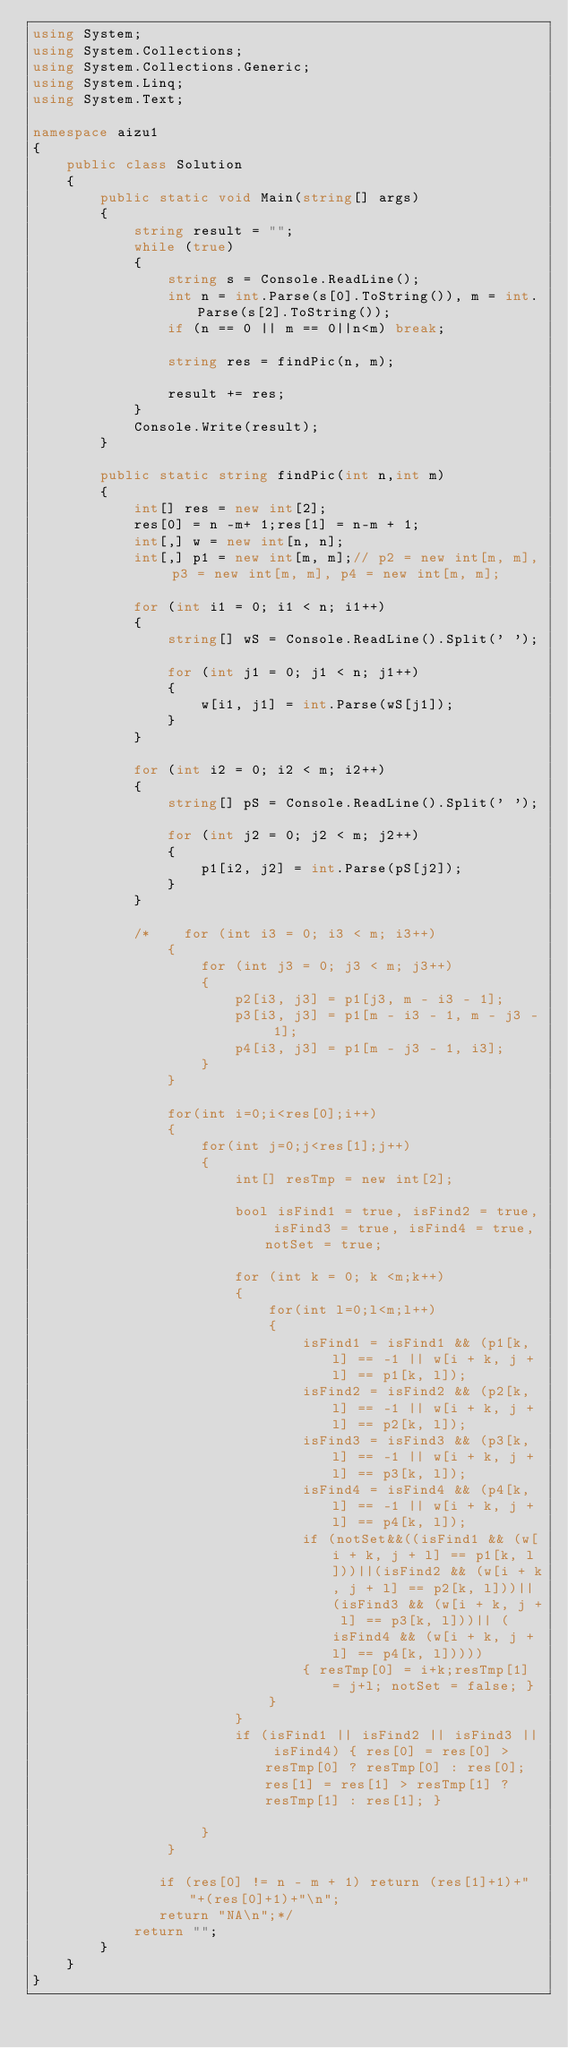<code> <loc_0><loc_0><loc_500><loc_500><_C#_>using System;
using System.Collections;
using System.Collections.Generic;
using System.Linq;
using System.Text;

namespace aizu1
{
    public class Solution
    {
        public static void Main(string[] args)
        {
            string result = "";
            while (true)
            {
                string s = Console.ReadLine();
                int n = int.Parse(s[0].ToString()), m = int.Parse(s[2].ToString());
                if (n == 0 || m == 0||n<m) break;

                string res = findPic(n, m);

                result += res;
            }
            Console.Write(result);   
        }
        
        public static string findPic(int n,int m)
        {
            int[] res = new int[2];
            res[0] = n -m+ 1;res[1] = n-m + 1;
            int[,] w = new int[n, n];
            int[,] p1 = new int[m, m];// p2 = new int[m, m], p3 = new int[m, m], p4 = new int[m, m];

            for (int i1 = 0; i1 < n; i1++)
            {
                string[] wS = Console.ReadLine().Split(' ');

                for (int j1 = 0; j1 < n; j1++)
                {
                    w[i1, j1] = int.Parse(wS[j1]);
                }
            }

            for (int i2 = 0; i2 < m; i2++)
            {
                string[] pS = Console.ReadLine().Split(' ');

                for (int j2 = 0; j2 < m; j2++)
                {
                    p1[i2, j2] = int.Parse(pS[j2]);
                }
            }

            /*    for (int i3 = 0; i3 < m; i3++)
                {
                    for (int j3 = 0; j3 < m; j3++)
                    {
                        p2[i3, j3] = p1[j3, m - i3 - 1];
                        p3[i3, j3] = p1[m - i3 - 1, m - j3 - 1];
                        p4[i3, j3] = p1[m - j3 - 1, i3];
                    }
                }

                for(int i=0;i<res[0];i++)
                {
                    for(int j=0;j<res[1];j++)
                    {
                        int[] resTmp = new int[2];

                        bool isFind1 = true, isFind2 = true, isFind3 = true, isFind4 = true, notSet = true;

                        for (int k = 0; k <m;k++)
                        {
                            for(int l=0;l<m;l++)
                            {
                                isFind1 = isFind1 && (p1[k, l] == -1 || w[i + k, j + l] == p1[k, l]);
                                isFind2 = isFind2 && (p2[k, l] == -1 || w[i + k, j + l] == p2[k, l]);
                                isFind3 = isFind3 && (p3[k, l] == -1 || w[i + k, j + l] == p3[k, l]);
                                isFind4 = isFind4 && (p4[k, l] == -1 || w[i + k, j + l] == p4[k, l]);
                                if (notSet&&((isFind1 && (w[i + k, j + l] == p1[k, l]))||(isFind2 && (w[i + k, j + l] == p2[k, l]))|| (isFind3 && (w[i + k, j + l] == p3[k, l]))|| (isFind4 && (w[i + k, j + l] == p4[k, l]))))
                                { resTmp[0] = i+k;resTmp[1] = j+l; notSet = false; }
                            }
                        }
                        if (isFind1 || isFind2 || isFind3 || isFind4) { res[0] = res[0] > resTmp[0] ? resTmp[0] : res[0]; res[1] = res[1] > resTmp[1] ? resTmp[1] : res[1]; } 

                    }
                }

               if (res[0] != n - m + 1) return (res[1]+1)+" "+(res[0]+1)+"\n";
               return "NA\n";*/
            return "";
        }
    }
}</code> 